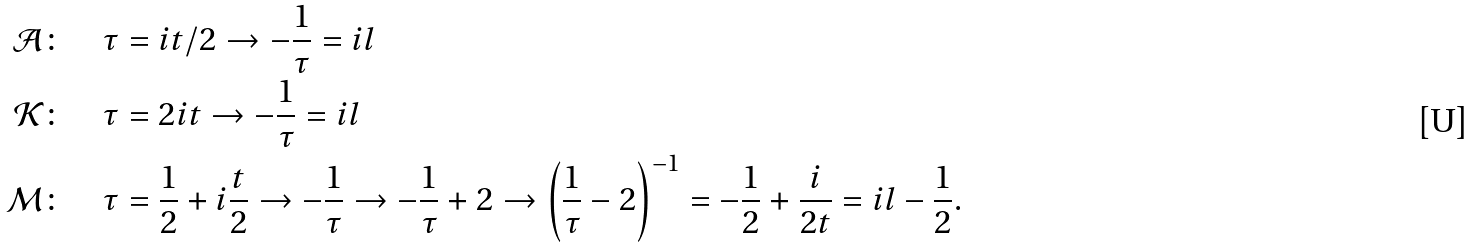<formula> <loc_0><loc_0><loc_500><loc_500>\mathcal { A } \colon & \quad \tau = i t / 2 \rightarrow - \frac { 1 } { \tau } = i l \\ \mathcal { K } \colon & \quad \tau = 2 i t \rightarrow - \frac { 1 } { \tau } = i l \\ \mathcal { M } \colon & \quad \tau = \frac { 1 } { 2 } + i \frac { t } { 2 } \rightarrow - \frac { 1 } { \tau } \rightarrow - \frac { 1 } { \tau } + 2 \rightarrow \left ( \frac { 1 } { \tau } - 2 \right ) ^ { - 1 } = - \frac { 1 } { 2 } + \frac { i } { 2 t } = i l - \frac { 1 } { 2 } .</formula> 